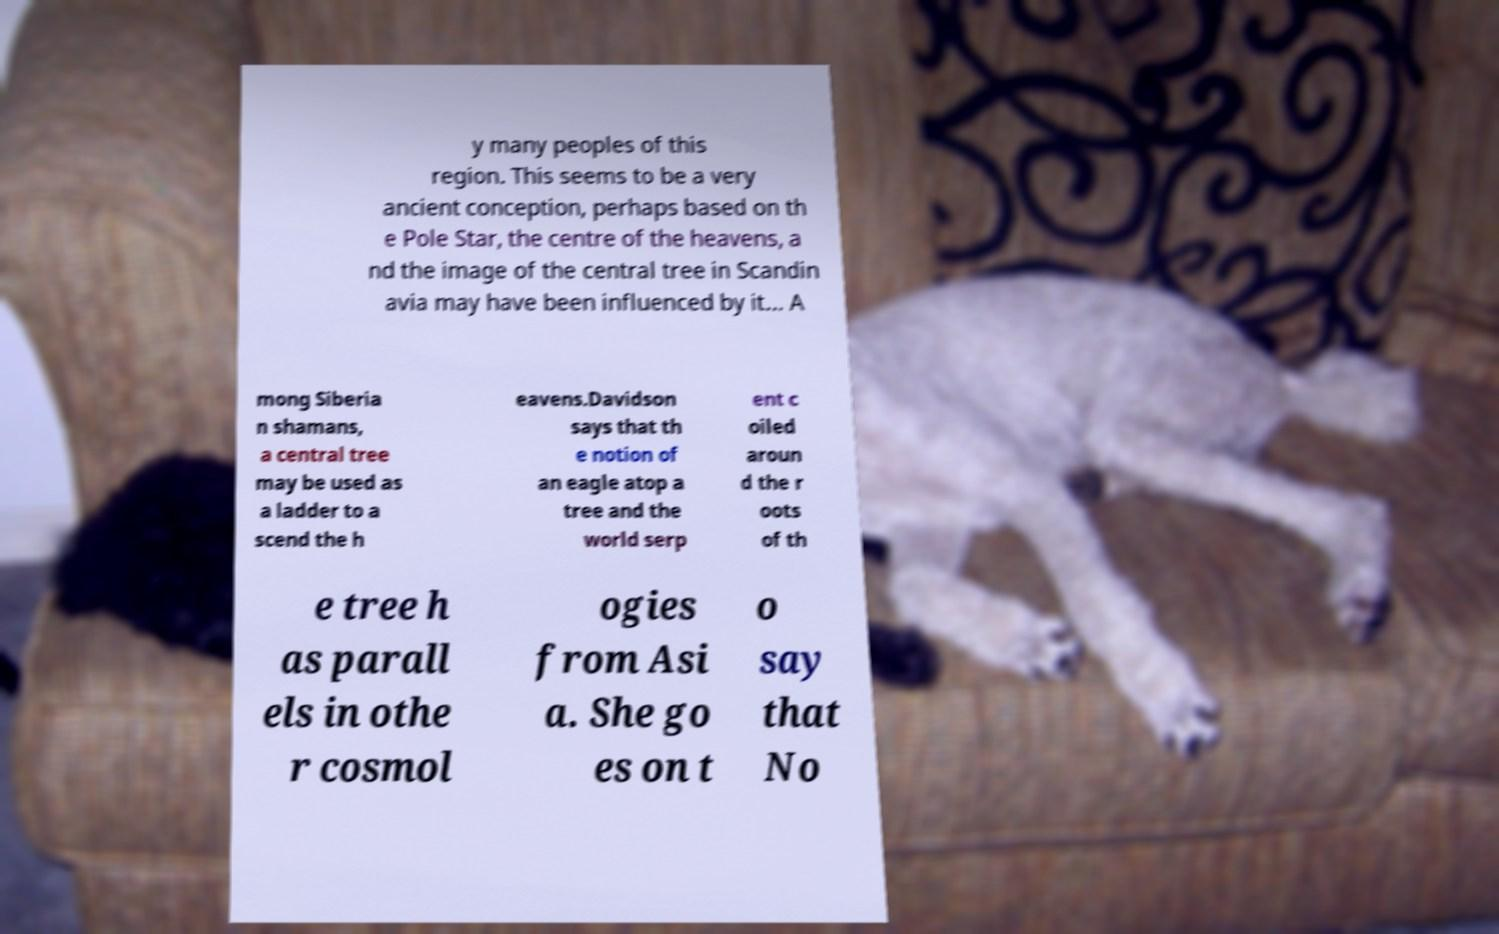Could you assist in decoding the text presented in this image and type it out clearly? y many peoples of this region. This seems to be a very ancient conception, perhaps based on th e Pole Star, the centre of the heavens, a nd the image of the central tree in Scandin avia may have been influenced by it... A mong Siberia n shamans, a central tree may be used as a ladder to a scend the h eavens.Davidson says that th e notion of an eagle atop a tree and the world serp ent c oiled aroun d the r oots of th e tree h as parall els in othe r cosmol ogies from Asi a. She go es on t o say that No 